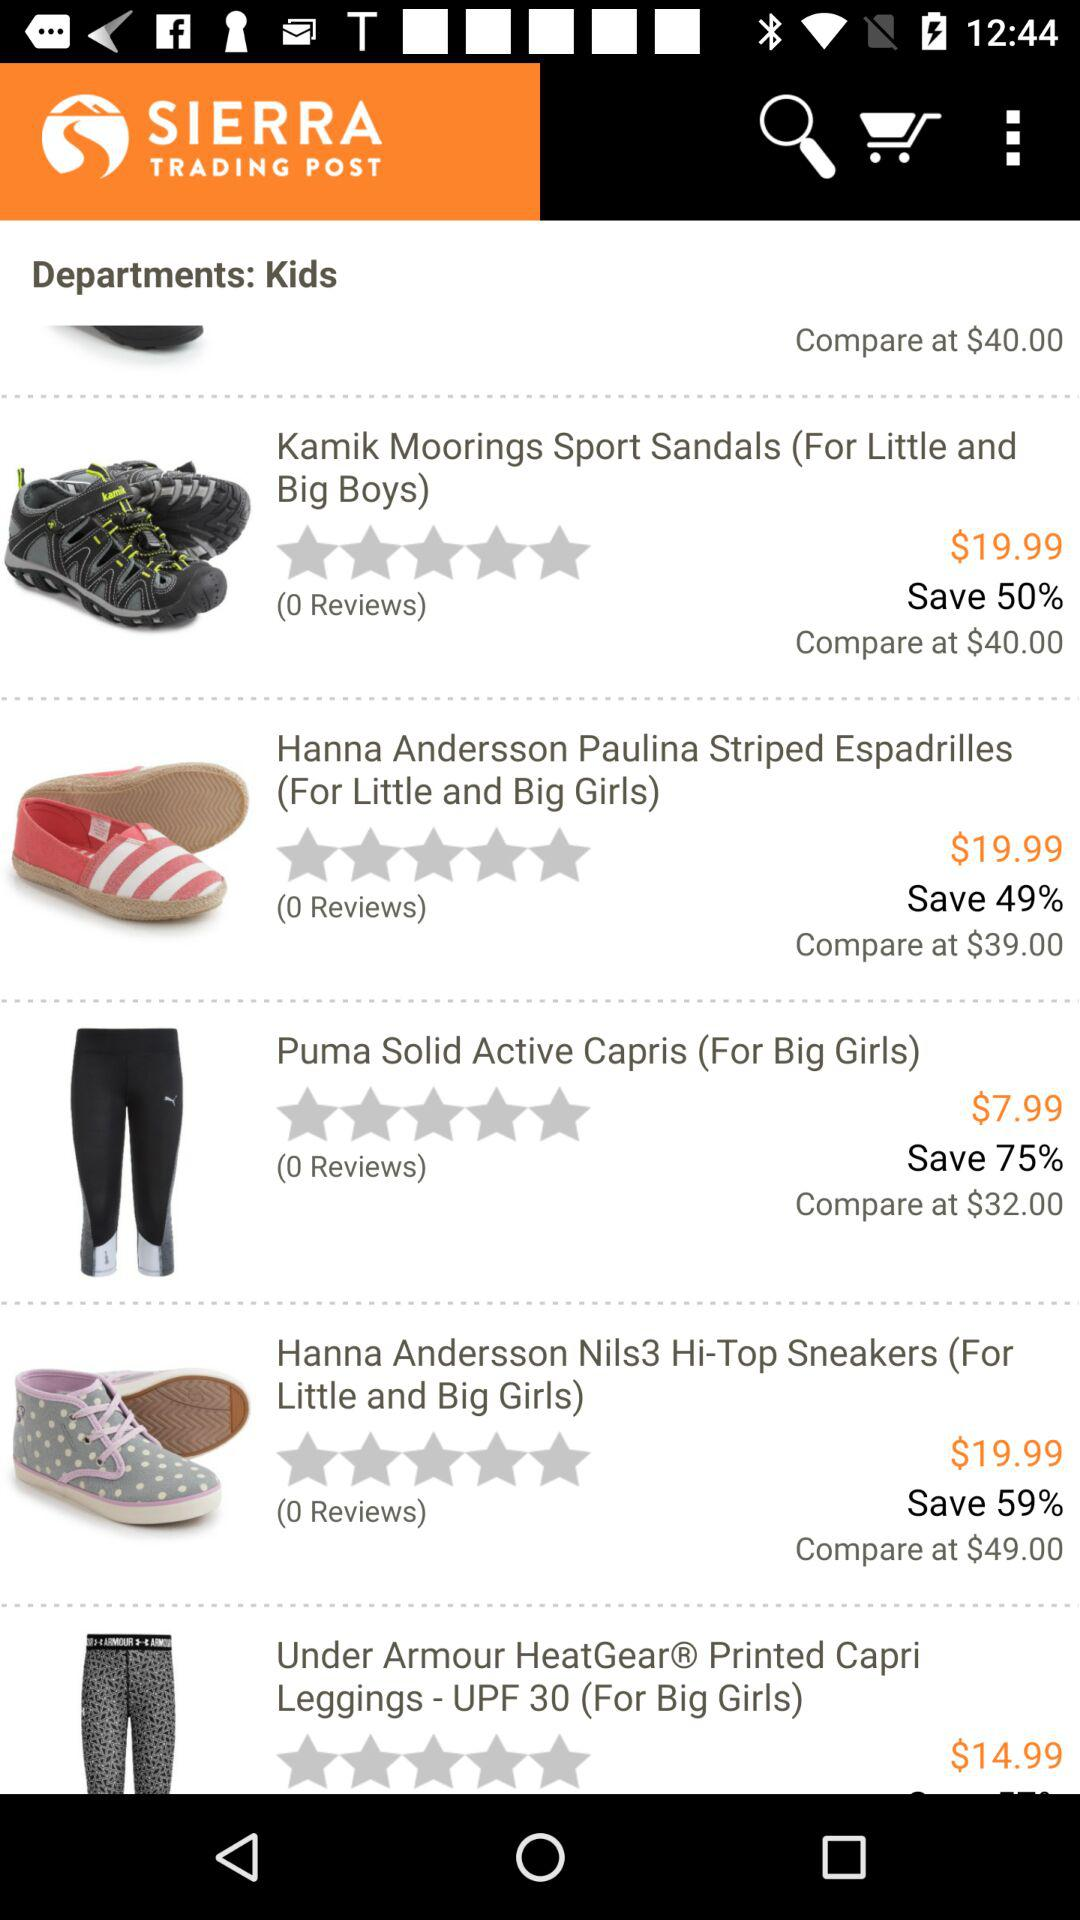What is the department? The department is "Kids". 